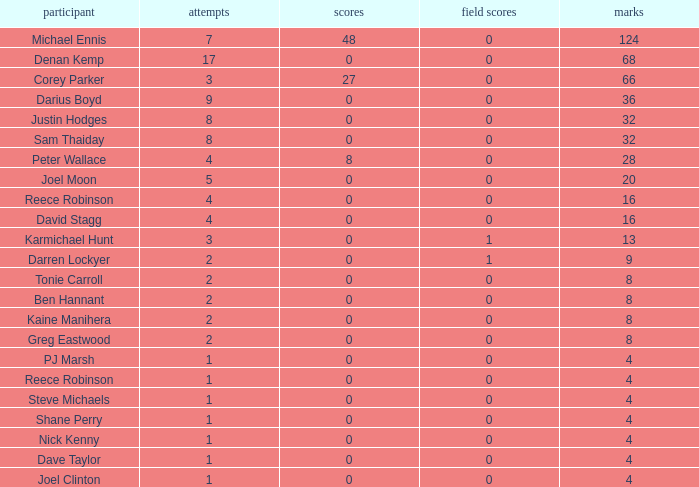What is the number of goals Dave Taylor, who has more than 1 tries, has? None. 